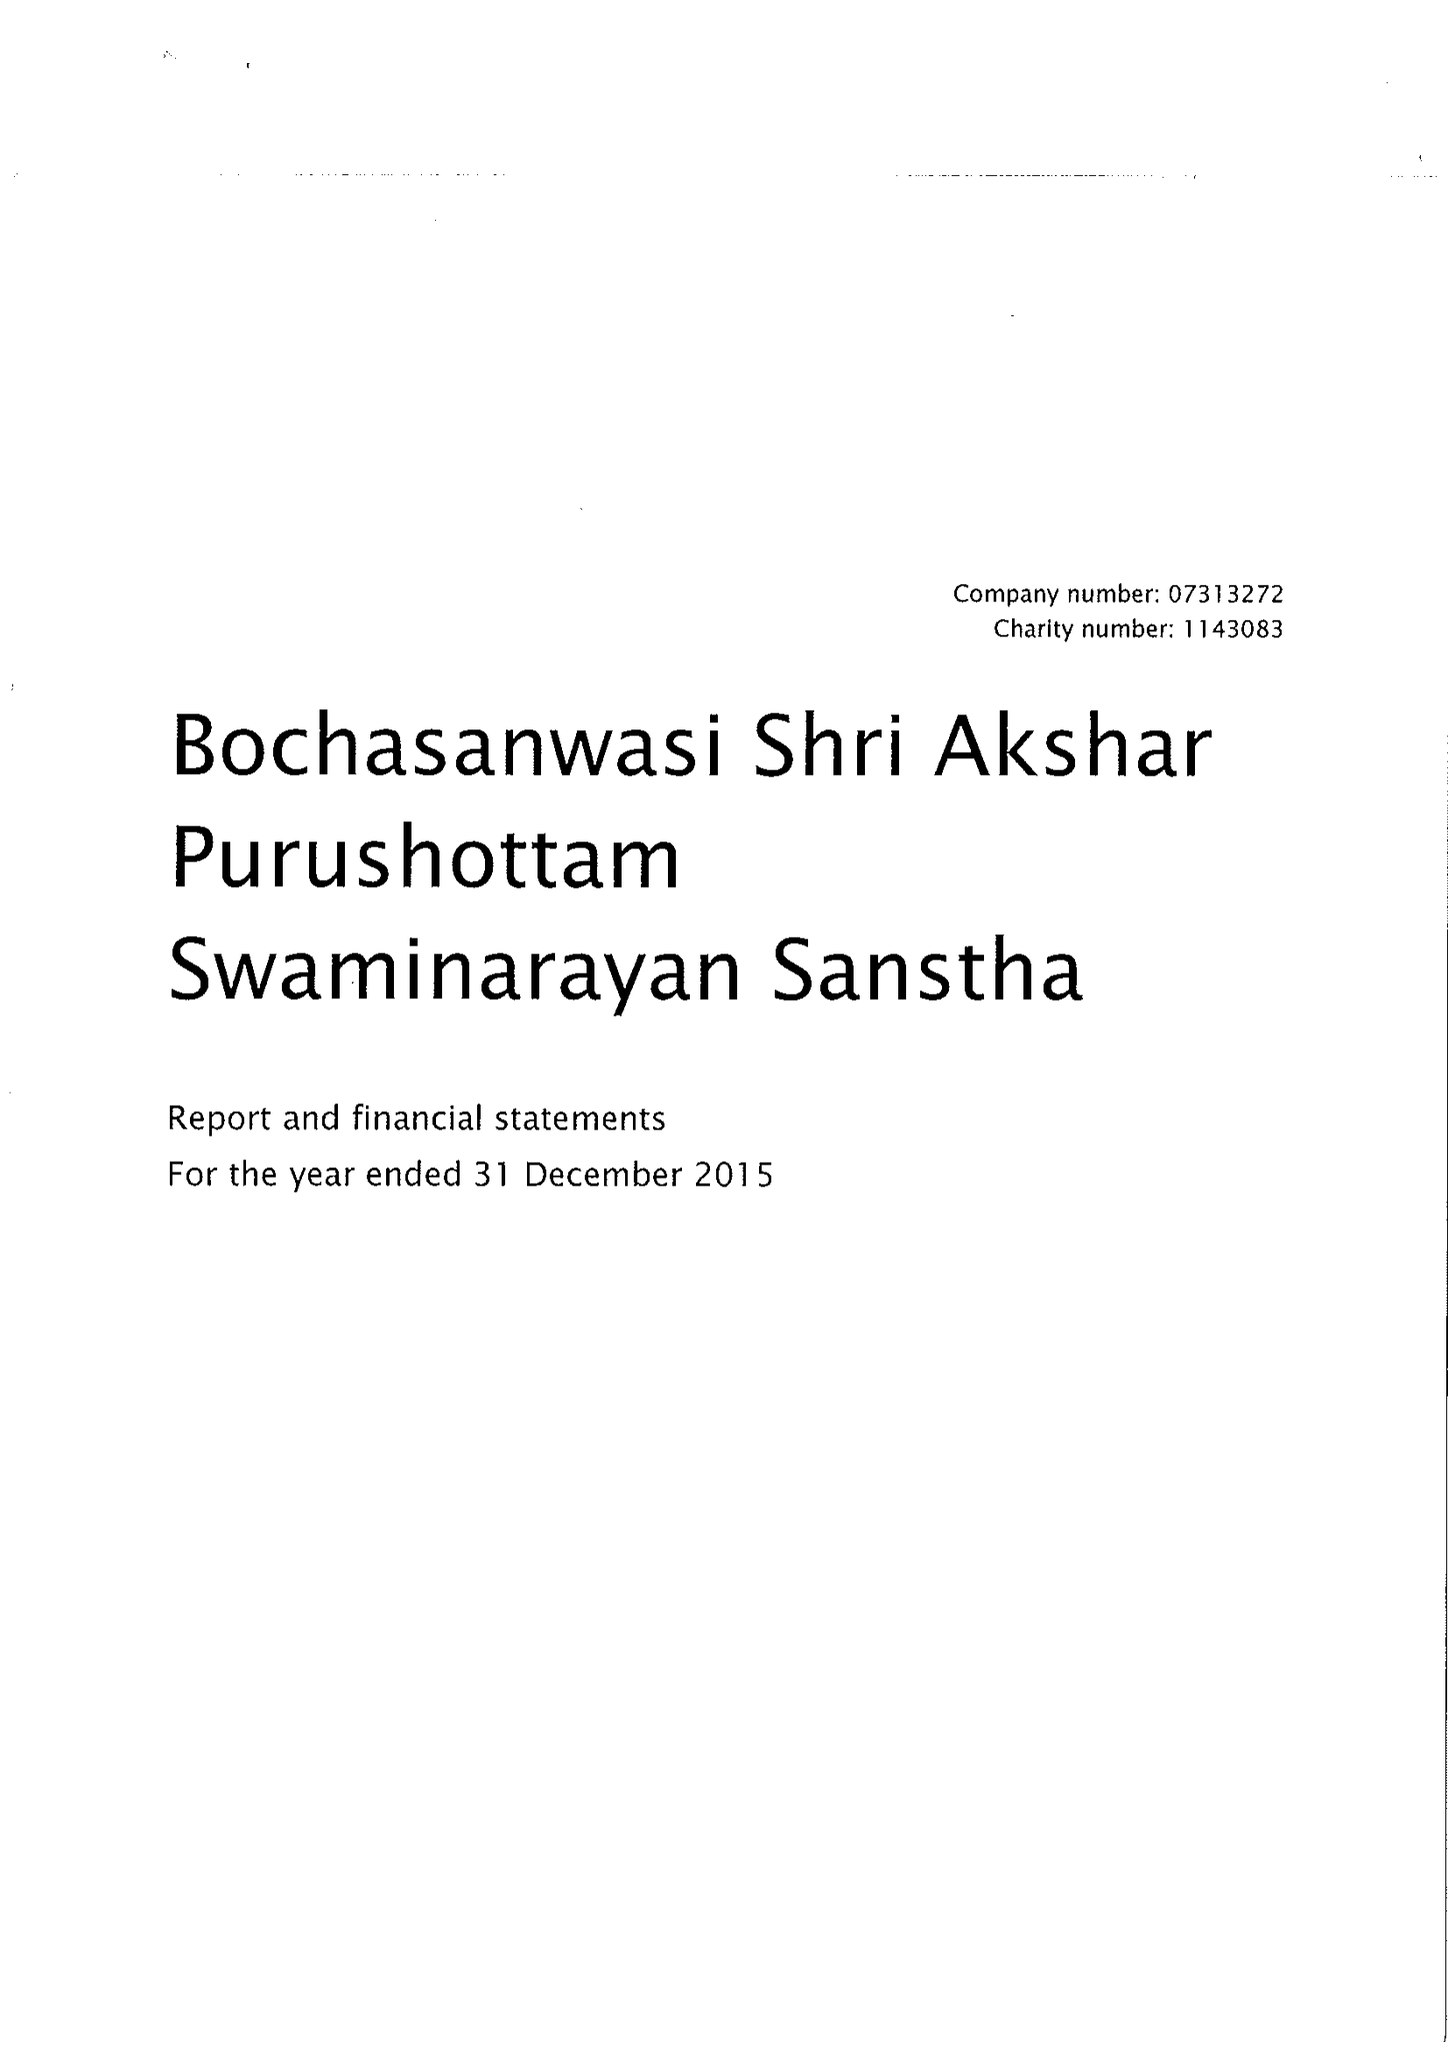What is the value for the spending_annually_in_british_pounds?
Answer the question using a single word or phrase. 9745279.00 